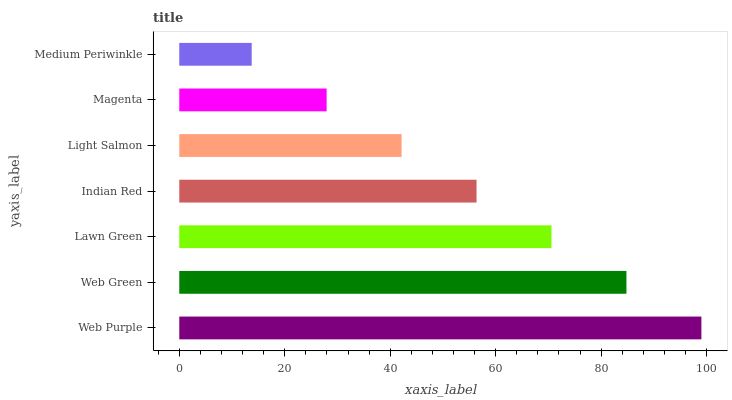Is Medium Periwinkle the minimum?
Answer yes or no. Yes. Is Web Purple the maximum?
Answer yes or no. Yes. Is Web Green the minimum?
Answer yes or no. No. Is Web Green the maximum?
Answer yes or no. No. Is Web Purple greater than Web Green?
Answer yes or no. Yes. Is Web Green less than Web Purple?
Answer yes or no. Yes. Is Web Green greater than Web Purple?
Answer yes or no. No. Is Web Purple less than Web Green?
Answer yes or no. No. Is Indian Red the high median?
Answer yes or no. Yes. Is Indian Red the low median?
Answer yes or no. Yes. Is Web Green the high median?
Answer yes or no. No. Is Web Green the low median?
Answer yes or no. No. 